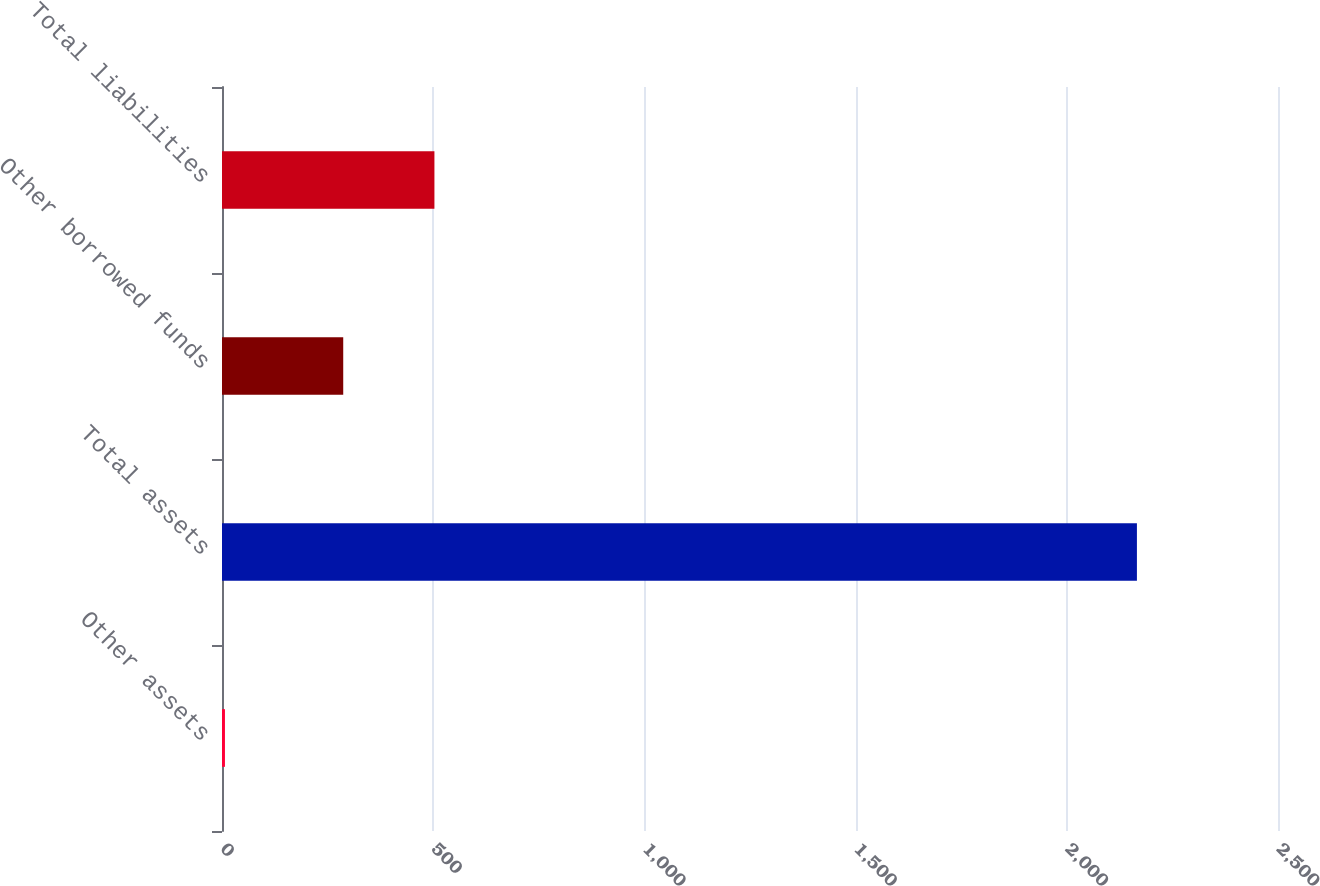<chart> <loc_0><loc_0><loc_500><loc_500><bar_chart><fcel>Other assets<fcel>Total assets<fcel>Other borrowed funds<fcel>Total liabilities<nl><fcel>7<fcel>2166<fcel>287<fcel>502.9<nl></chart> 